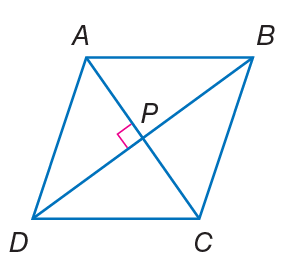Answer the mathemtical geometry problem and directly provide the correct option letter.
Question: Quadrilateral A B C D is a rhombus. If m \angle D P C = 3 x - 15, find x.
Choices: A: 14 B: 35 C: 56 D: 90 B 